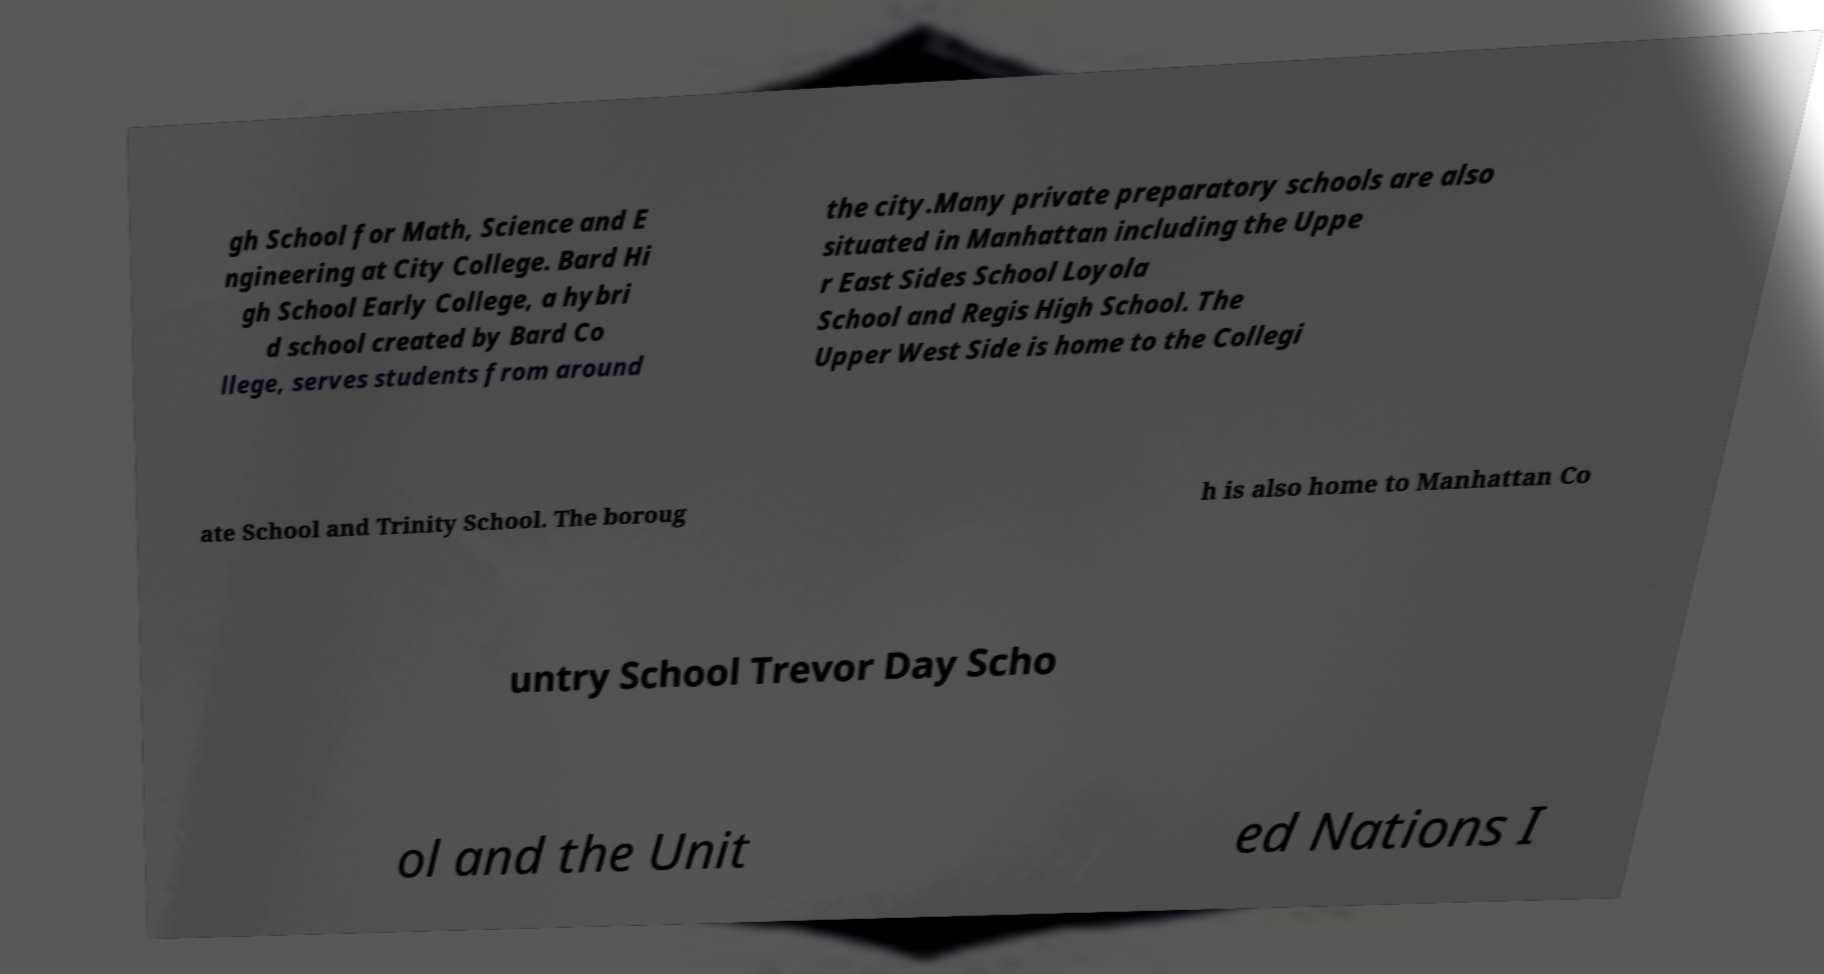Could you assist in decoding the text presented in this image and type it out clearly? gh School for Math, Science and E ngineering at City College. Bard Hi gh School Early College, a hybri d school created by Bard Co llege, serves students from around the city.Many private preparatory schools are also situated in Manhattan including the Uppe r East Sides School Loyola School and Regis High School. The Upper West Side is home to the Collegi ate School and Trinity School. The boroug h is also home to Manhattan Co untry School Trevor Day Scho ol and the Unit ed Nations I 